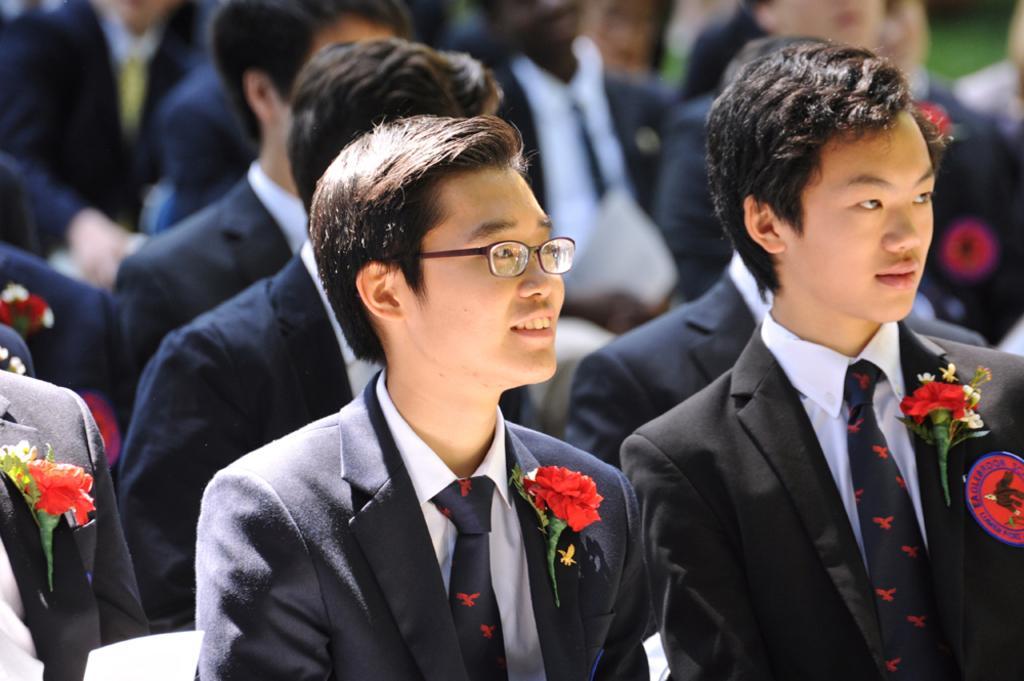Could you give a brief overview of what you see in this image? There is a group of persons sitting on the chairs as we can see in the middle of this image. There are some flowers on the blazers as we can see at the bottom of this image. 